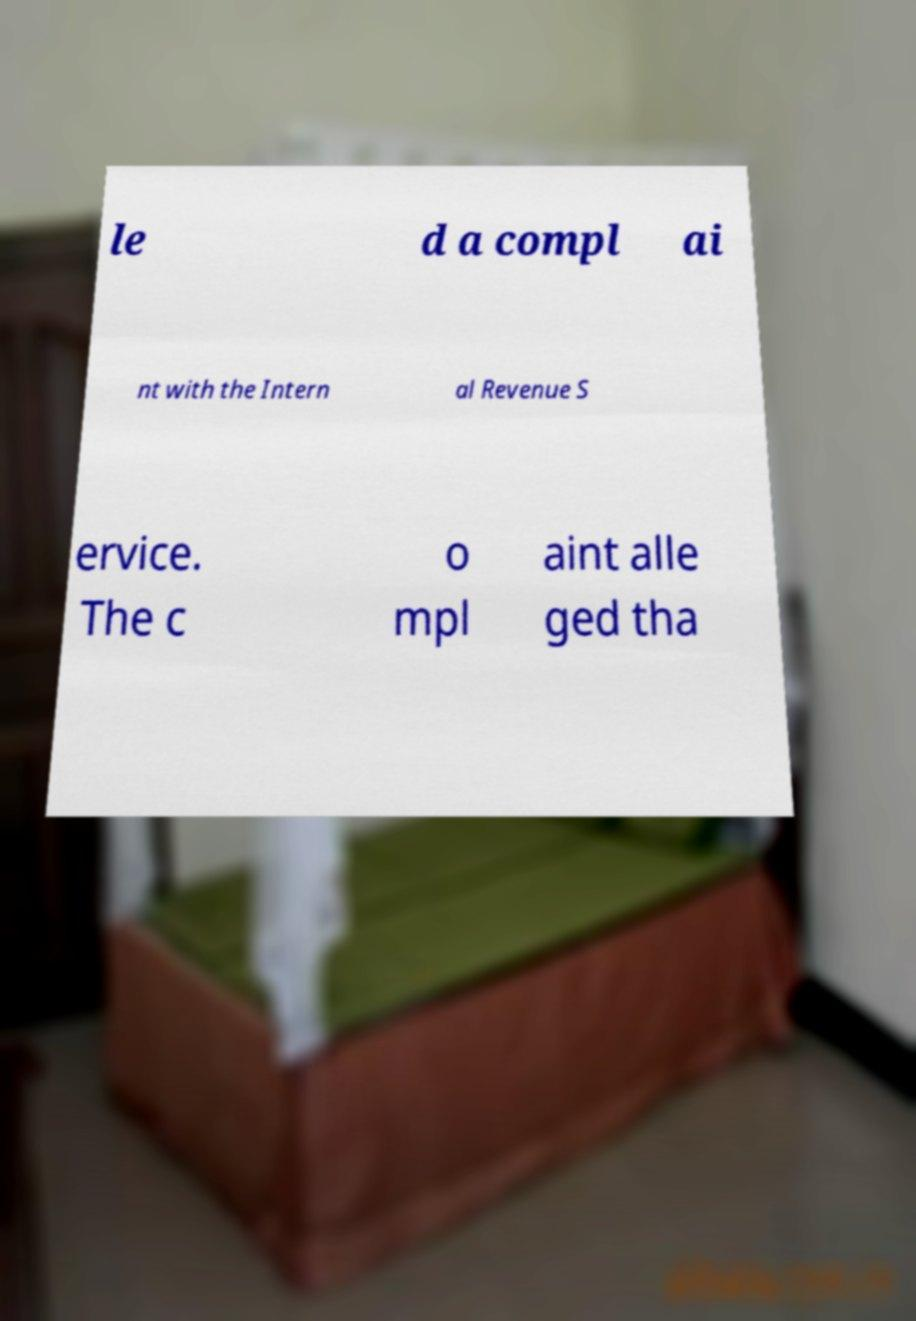Could you assist in decoding the text presented in this image and type it out clearly? le d a compl ai nt with the Intern al Revenue S ervice. The c o mpl aint alle ged tha 